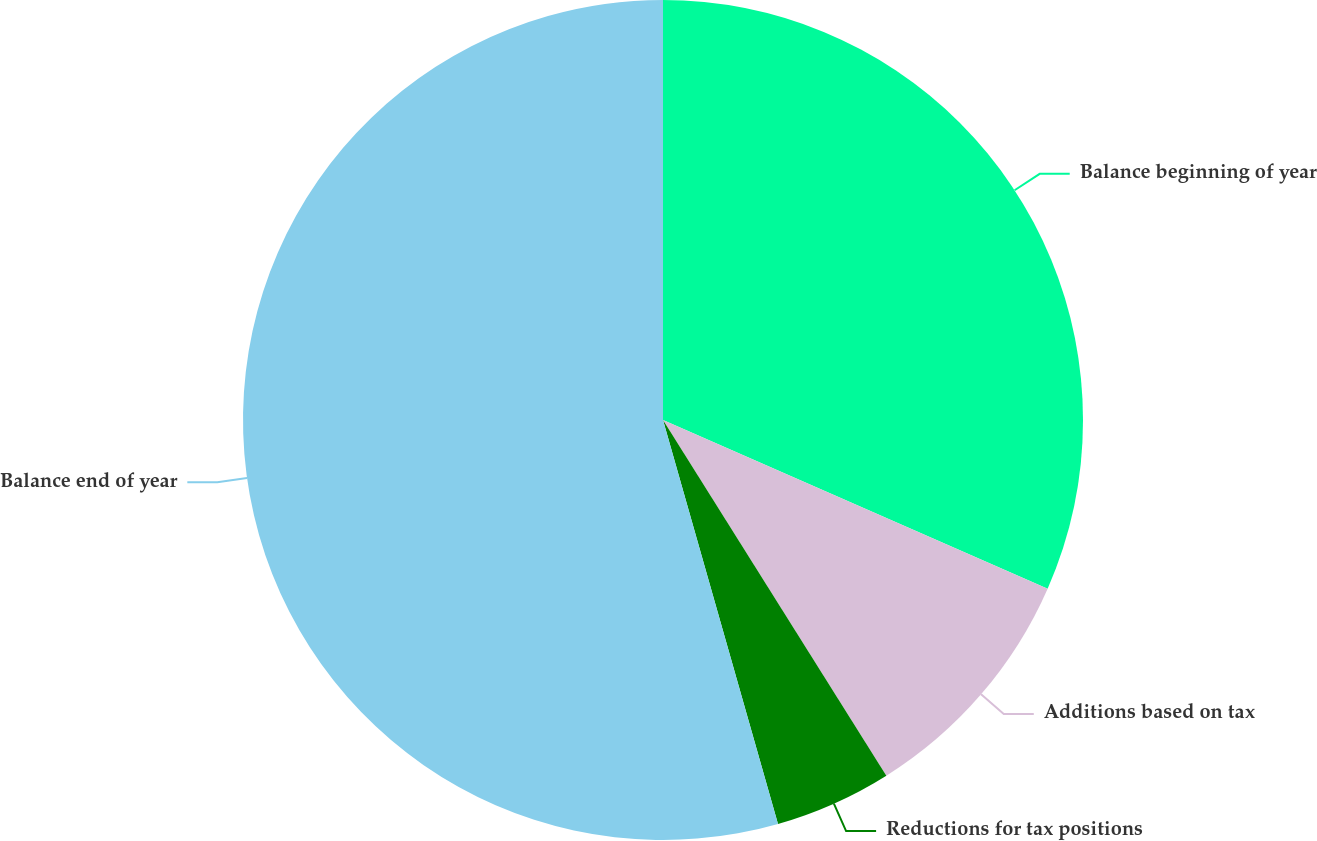<chart> <loc_0><loc_0><loc_500><loc_500><pie_chart><fcel>Balance beginning of year<fcel>Additions based on tax<fcel>Reductions for tax positions<fcel>Balance end of year<nl><fcel>31.58%<fcel>9.5%<fcel>4.51%<fcel>54.42%<nl></chart> 